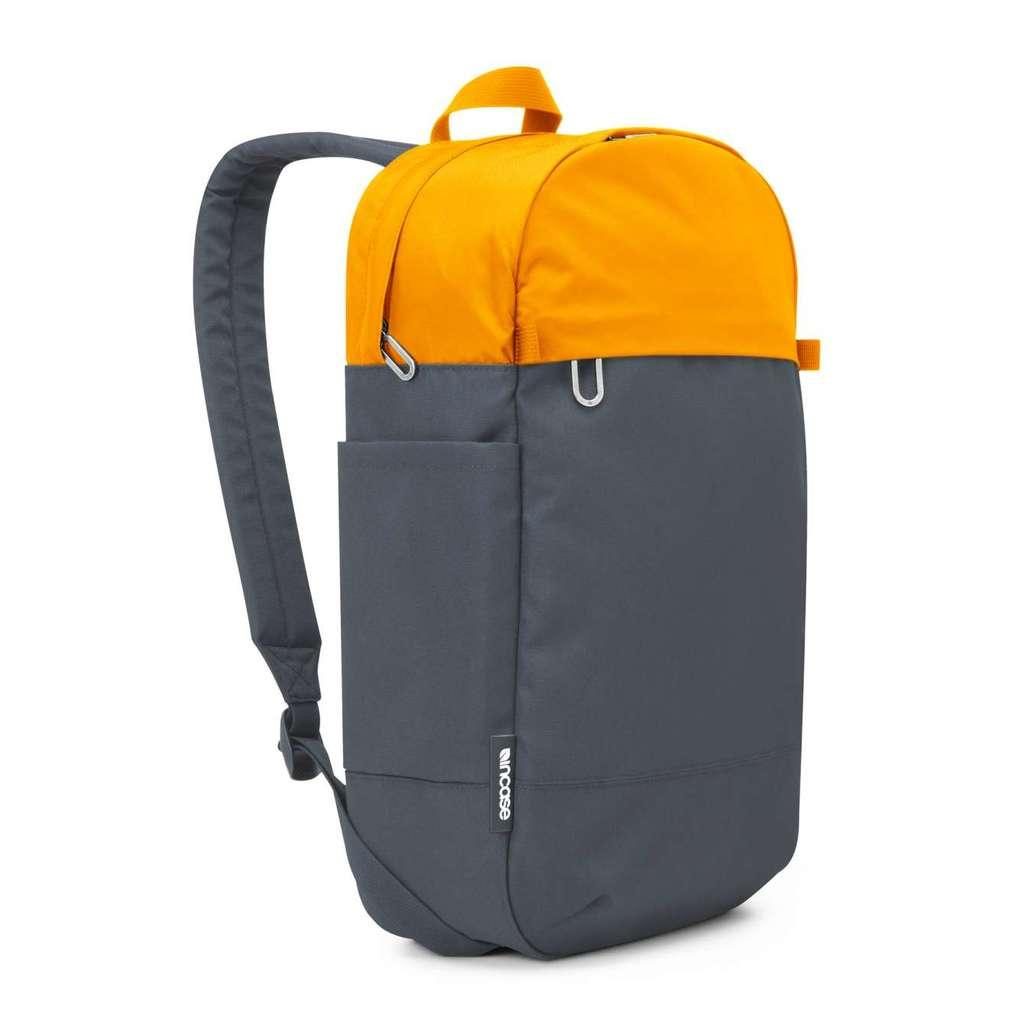What object can be seen in the image? There is a backpack in the image. What colors are present on the backpack? The backpack is black and yellow in color. Is there a river flowing through the backpack in the image? No, there is no river present in the image, and the backpack is not depicted as containing a river. 